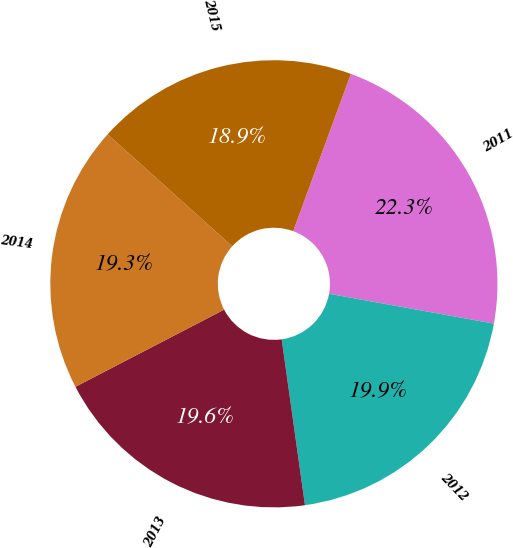Convert chart to OTSL. <chart><loc_0><loc_0><loc_500><loc_500><pie_chart><fcel>2011<fcel>2012<fcel>2013<fcel>2014<fcel>2015<nl><fcel>22.25%<fcel>19.93%<fcel>19.6%<fcel>19.27%<fcel>18.94%<nl></chart> 